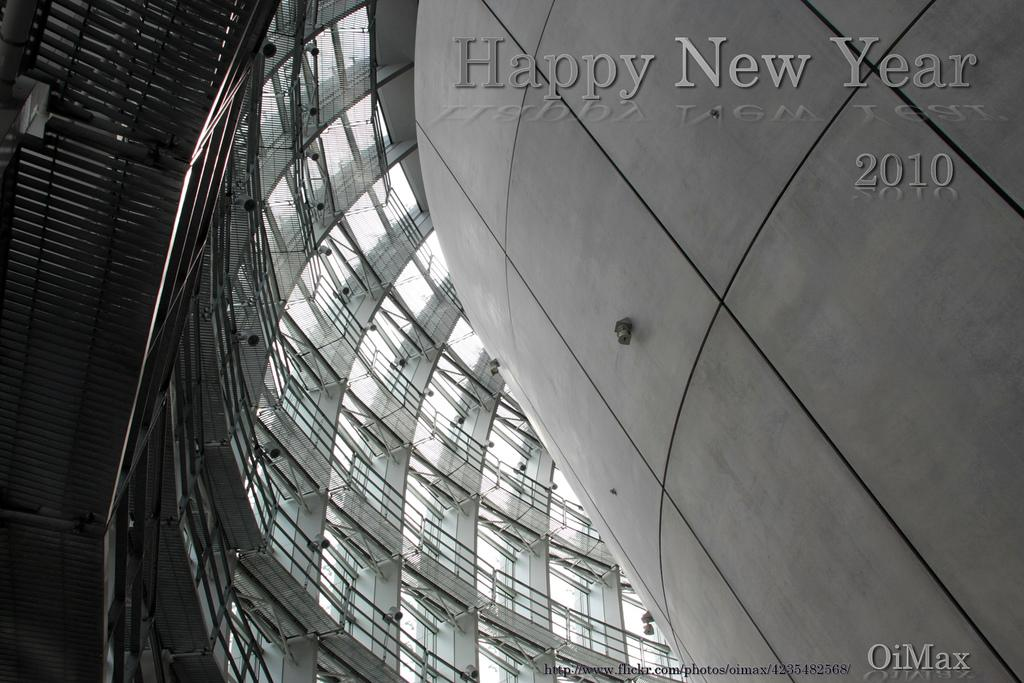What is the color scheme of the image? The image is black and white. What type of architectural feature can be seen in the image? There are glass windows in the image. Are there any additional details visible in the image? Watermarks are visible in the image. What type of pen is the beetle holding in the image? There is no beetle or pen present in the image; it is a black and white image with glass windows and watermarks. 